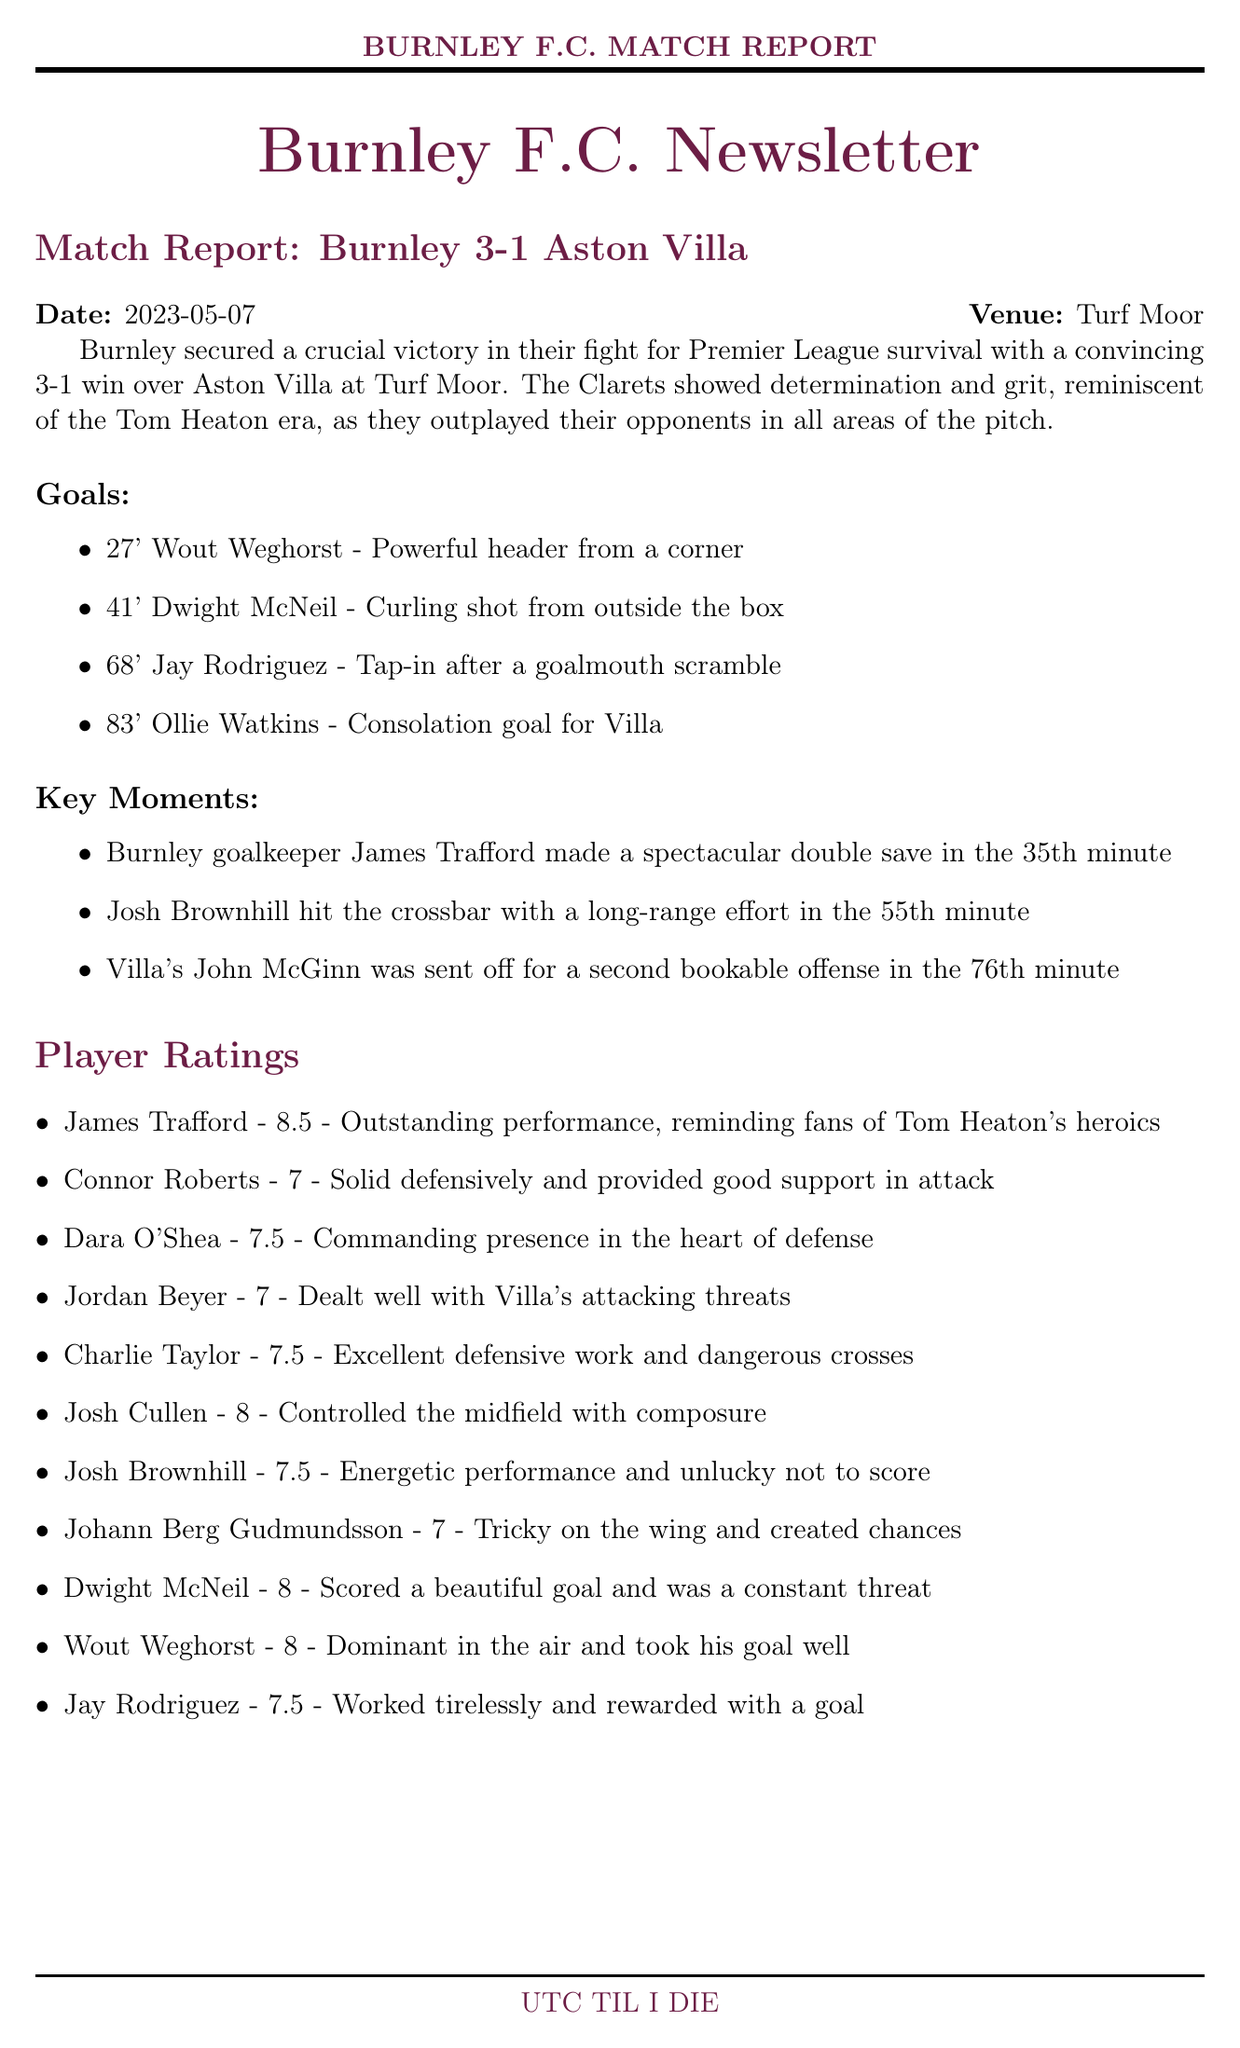what was the result of the match? The document states that Burnley secured a victory with a score of 3-1 against Aston Villa.
Answer: Burnley 3-1 Aston Villa who scored Burnley's first goal? According to the document, Wout Weghorst scored the first goal in the 27th minute.
Answer: Wout Weghorst what was James Trafford's player rating? The player ratings indicate that James Trafford received a score of 8.5 for his performance.
Answer: 8.5 how many goals did Aston Villa score? The match report mentions that Aston Villa scored one goal.
Answer: 1 what key moment involved James Trafford? The document highlights that James Trafford made a spectacular double save in the 35th minute as a key moment.
Answer: Spectacular double save in the 35th minute who was considered the player of the match by fans? According to the fan perspective, many fans agreed that Dwight McNeil's performance was worthy of the Man of the Match award.
Answer: Dwight McNeil what was the atmosphere described at Turf Moor? The document describes the atmosphere at Turf Moor as electric, with fans chanting Tom Heaton's name.
Answer: Electric how did Burnley's victory impact their survival chances? The newsletter indicates that the victory significantly improved Burnley's chances of avoiding relegation.
Answer: Significantly improved what were James Trafford's key stats? The document lists James Trafford's key stats: 6 saves, 0 clean sheets, and 89% pass accuracy.
Answer: 6 saves, 0 clean sheets, 89% pass accuracy 